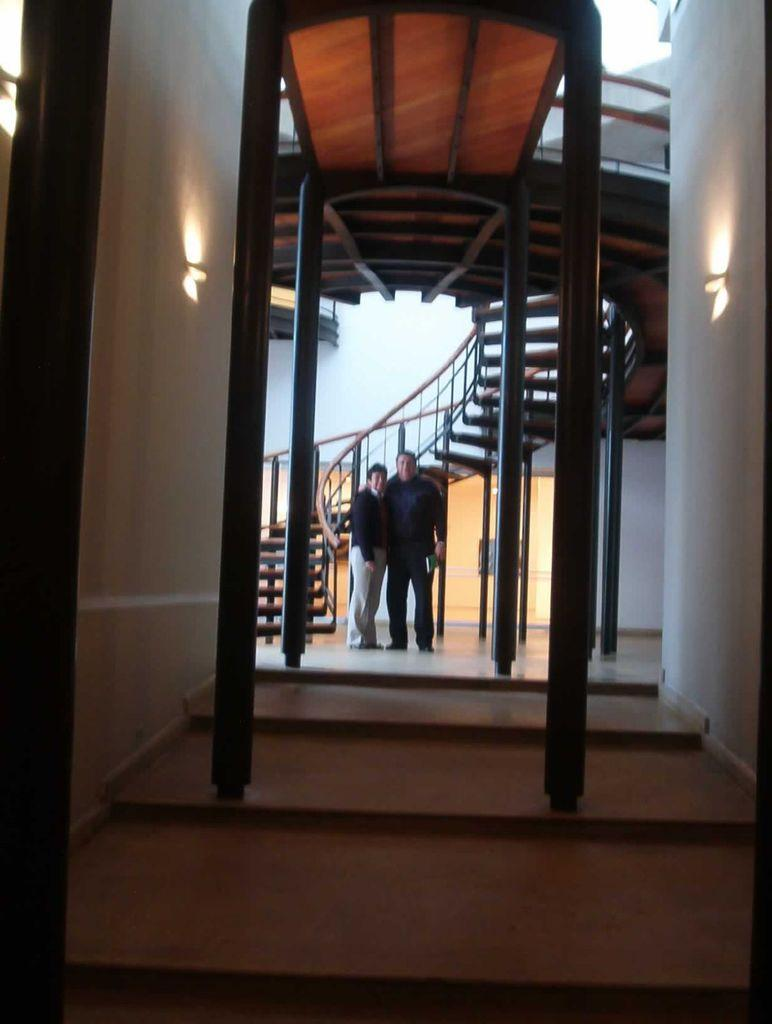How many people are present in the image? There are two people standing in the image. What surface are the people standing on? The people are standing on the floor. What can be seen in the background of the image? There is a wall in the image. Are there any architectural features visible in the image? Yes, there is a staircase in the image. What other items can be seen in the image? There are some objects in the image. Can you tell me how many wings are attached to the ball in the image? There is no ball or wings present in the image. 